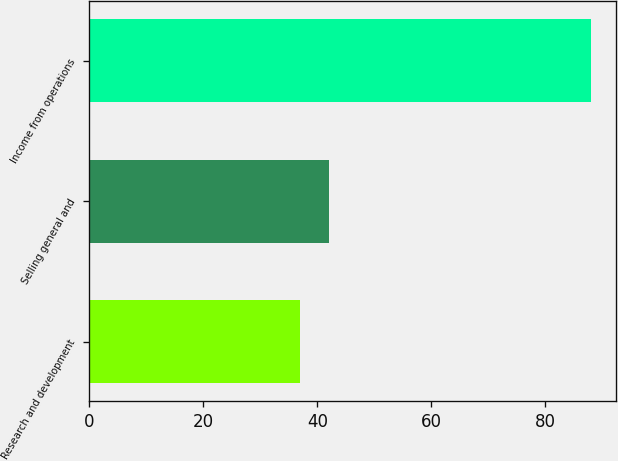Convert chart. <chart><loc_0><loc_0><loc_500><loc_500><bar_chart><fcel>Research and development<fcel>Selling general and<fcel>Income from operations<nl><fcel>37<fcel>42.1<fcel>88<nl></chart> 